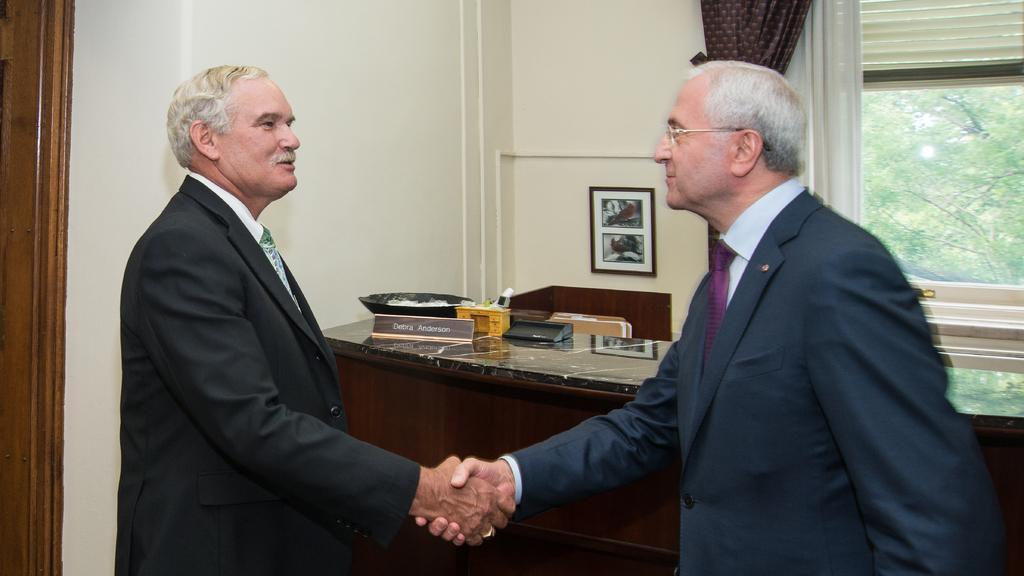How would you summarize this image in a sentence or two? This picture is clicked inside the room. In the center we can see the two men wearing suits, standing and shaking their hands. In the background we can see a picture frame hanging on the wall and we can see the curtain, window, window blind and some objects placed on the top of the table and we can see some other objects. 